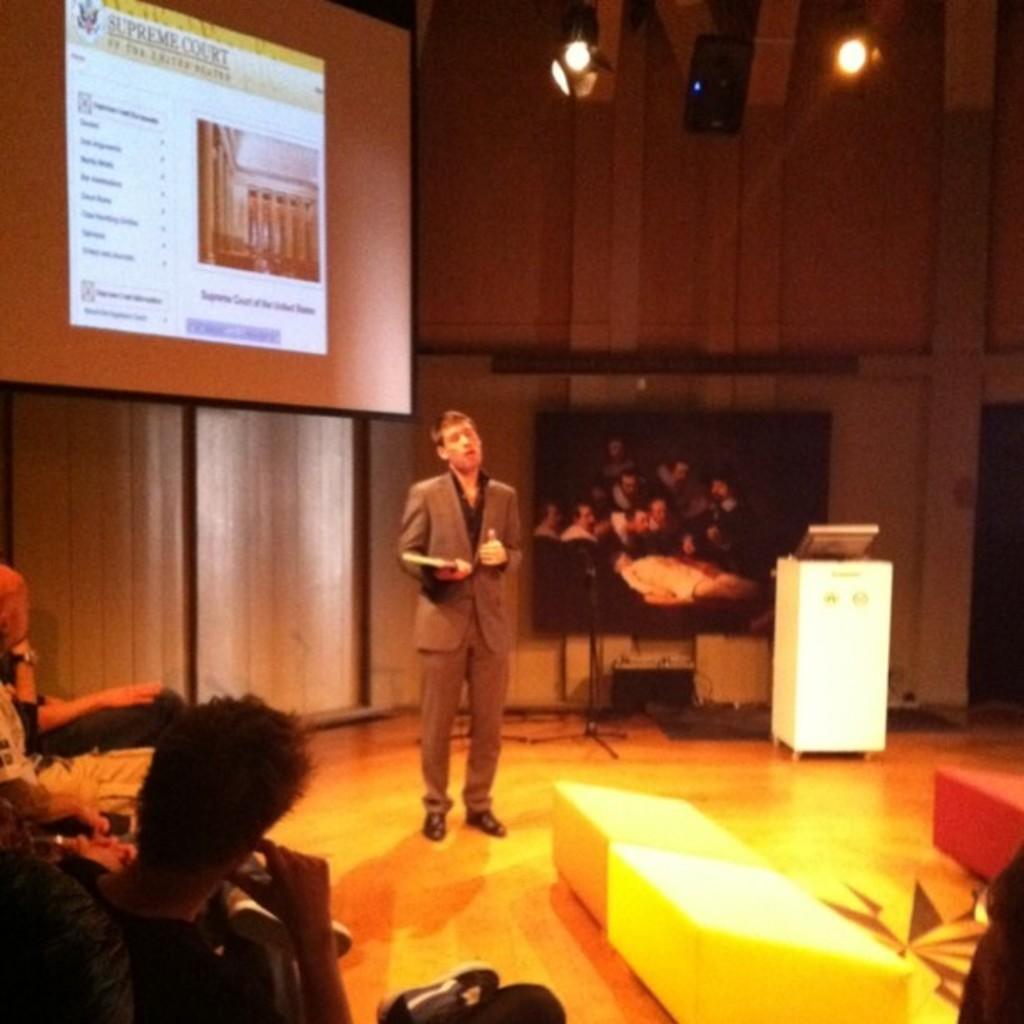Describe this image in one or two sentences. In this image I can see there is a person standing on the floor and holding an object. And in front of him it looks like an object. And there are persons sitting. And at the back there is a podium, stand and screen. And there is a photo frame. And there is a wall. And at the top there are lights and speaker. 